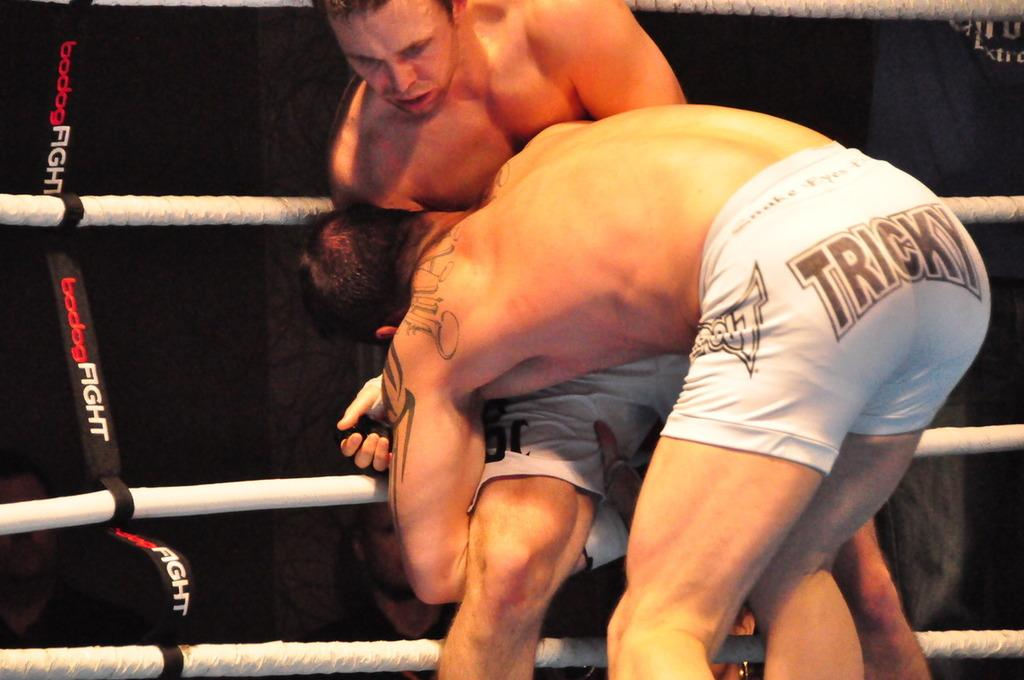<image>
Render a clear and concise summary of the photo. A man in a wrestling competition has the word "tricky" on his shorts. 